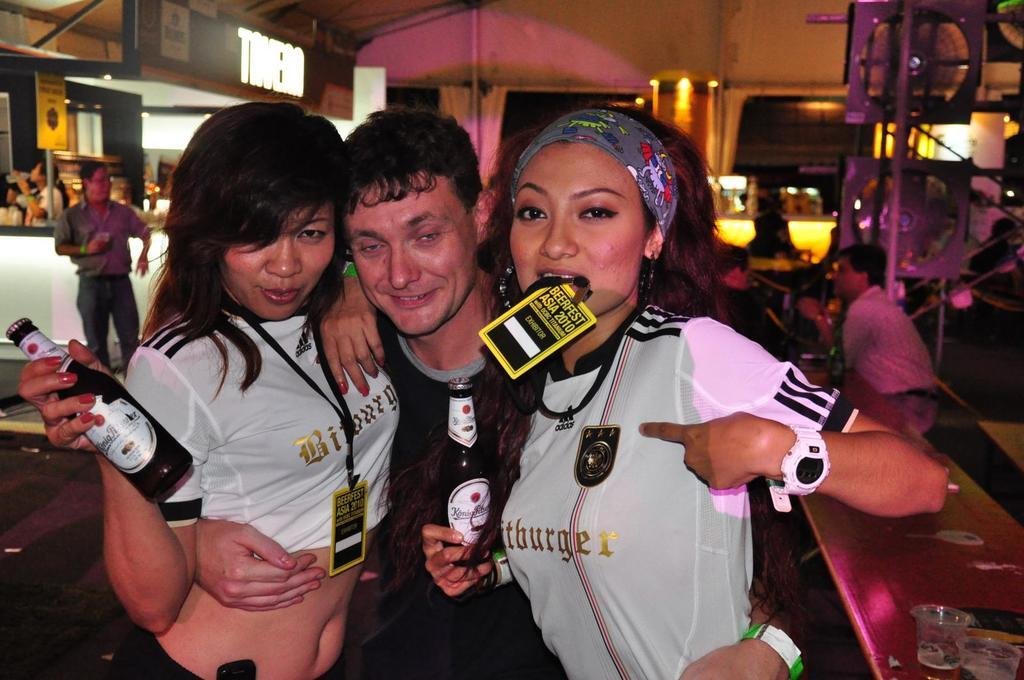How many people are in the image? There are three people in the image. What are the people doing in the image? The people are standing and holding bottles. What can be seen on the wall in the background of the image? There are boards on the wall in the background of the image. What type of truck can be seen parked next to the people in the image? There is no truck present in the image; it only features three people standing and holding bottles. Can you tell me how many pigs are visible in the image? There are no pigs present in the image. 